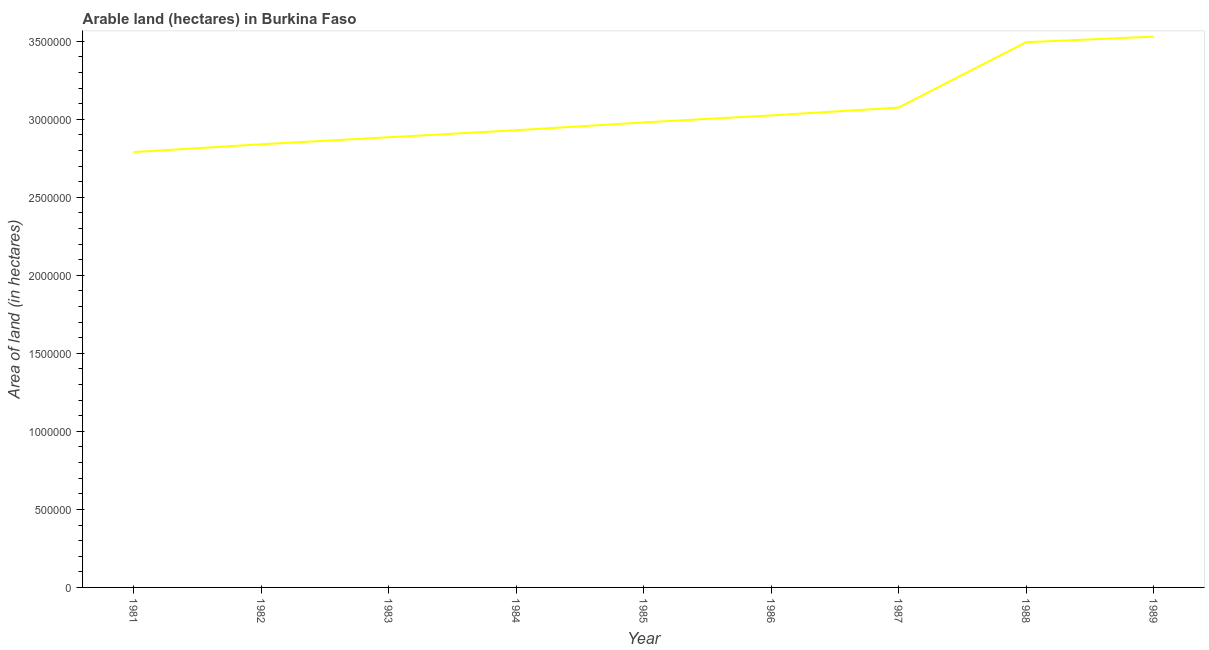What is the area of land in 1986?
Your response must be concise. 3.02e+06. Across all years, what is the maximum area of land?
Offer a very short reply. 3.53e+06. Across all years, what is the minimum area of land?
Your response must be concise. 2.79e+06. What is the sum of the area of land?
Ensure brevity in your answer.  2.75e+07. What is the difference between the area of land in 1981 and 1987?
Provide a short and direct response. -2.85e+05. What is the average area of land per year?
Keep it short and to the point. 3.06e+06. What is the median area of land?
Provide a succinct answer. 2.98e+06. In how many years, is the area of land greater than 2200000 hectares?
Offer a very short reply. 9. What is the ratio of the area of land in 1984 to that in 1987?
Offer a very short reply. 0.95. Is the area of land in 1986 less than that in 1989?
Provide a succinct answer. Yes. What is the difference between the highest and the second highest area of land?
Give a very brief answer. 3.60e+04. Is the sum of the area of land in 1984 and 1985 greater than the maximum area of land across all years?
Provide a succinct answer. Yes. What is the difference between the highest and the lowest area of land?
Your answer should be very brief. 7.40e+05. In how many years, is the area of land greater than the average area of land taken over all years?
Make the answer very short. 3. Does the area of land monotonically increase over the years?
Give a very brief answer. Yes. How many years are there in the graph?
Offer a terse response. 9. What is the difference between two consecutive major ticks on the Y-axis?
Keep it short and to the point. 5.00e+05. Does the graph contain grids?
Offer a very short reply. No. What is the title of the graph?
Provide a short and direct response. Arable land (hectares) in Burkina Faso. What is the label or title of the Y-axis?
Your answer should be compact. Area of land (in hectares). What is the Area of land (in hectares) in 1981?
Make the answer very short. 2.79e+06. What is the Area of land (in hectares) of 1982?
Your response must be concise. 2.84e+06. What is the Area of land (in hectares) in 1983?
Your answer should be compact. 2.88e+06. What is the Area of land (in hectares) of 1984?
Make the answer very short. 2.93e+06. What is the Area of land (in hectares) in 1985?
Keep it short and to the point. 2.98e+06. What is the Area of land (in hectares) of 1986?
Provide a succinct answer. 3.02e+06. What is the Area of land (in hectares) of 1987?
Your answer should be compact. 3.08e+06. What is the Area of land (in hectares) in 1988?
Your answer should be very brief. 3.49e+06. What is the Area of land (in hectares) of 1989?
Give a very brief answer. 3.53e+06. What is the difference between the Area of land (in hectares) in 1981 and 1983?
Your response must be concise. -9.50e+04. What is the difference between the Area of land (in hectares) in 1981 and 1986?
Keep it short and to the point. -2.35e+05. What is the difference between the Area of land (in hectares) in 1981 and 1987?
Ensure brevity in your answer.  -2.85e+05. What is the difference between the Area of land (in hectares) in 1981 and 1988?
Provide a succinct answer. -7.04e+05. What is the difference between the Area of land (in hectares) in 1981 and 1989?
Ensure brevity in your answer.  -7.40e+05. What is the difference between the Area of land (in hectares) in 1982 and 1983?
Provide a succinct answer. -4.50e+04. What is the difference between the Area of land (in hectares) in 1982 and 1986?
Offer a terse response. -1.85e+05. What is the difference between the Area of land (in hectares) in 1982 and 1987?
Offer a very short reply. -2.35e+05. What is the difference between the Area of land (in hectares) in 1982 and 1988?
Make the answer very short. -6.54e+05. What is the difference between the Area of land (in hectares) in 1982 and 1989?
Keep it short and to the point. -6.90e+05. What is the difference between the Area of land (in hectares) in 1983 and 1984?
Provide a short and direct response. -4.50e+04. What is the difference between the Area of land (in hectares) in 1983 and 1985?
Make the answer very short. -9.50e+04. What is the difference between the Area of land (in hectares) in 1983 and 1987?
Ensure brevity in your answer.  -1.90e+05. What is the difference between the Area of land (in hectares) in 1983 and 1988?
Your answer should be very brief. -6.09e+05. What is the difference between the Area of land (in hectares) in 1983 and 1989?
Ensure brevity in your answer.  -6.45e+05. What is the difference between the Area of land (in hectares) in 1984 and 1986?
Ensure brevity in your answer.  -9.50e+04. What is the difference between the Area of land (in hectares) in 1984 and 1987?
Keep it short and to the point. -1.45e+05. What is the difference between the Area of land (in hectares) in 1984 and 1988?
Offer a terse response. -5.64e+05. What is the difference between the Area of land (in hectares) in 1984 and 1989?
Ensure brevity in your answer.  -6.00e+05. What is the difference between the Area of land (in hectares) in 1985 and 1986?
Provide a short and direct response. -4.50e+04. What is the difference between the Area of land (in hectares) in 1985 and 1987?
Your answer should be compact. -9.50e+04. What is the difference between the Area of land (in hectares) in 1985 and 1988?
Make the answer very short. -5.14e+05. What is the difference between the Area of land (in hectares) in 1985 and 1989?
Provide a short and direct response. -5.50e+05. What is the difference between the Area of land (in hectares) in 1986 and 1987?
Your answer should be very brief. -5.00e+04. What is the difference between the Area of land (in hectares) in 1986 and 1988?
Keep it short and to the point. -4.69e+05. What is the difference between the Area of land (in hectares) in 1986 and 1989?
Offer a terse response. -5.05e+05. What is the difference between the Area of land (in hectares) in 1987 and 1988?
Give a very brief answer. -4.19e+05. What is the difference between the Area of land (in hectares) in 1987 and 1989?
Keep it short and to the point. -4.55e+05. What is the difference between the Area of land (in hectares) in 1988 and 1989?
Give a very brief answer. -3.60e+04. What is the ratio of the Area of land (in hectares) in 1981 to that in 1982?
Keep it short and to the point. 0.98. What is the ratio of the Area of land (in hectares) in 1981 to that in 1985?
Make the answer very short. 0.94. What is the ratio of the Area of land (in hectares) in 1981 to that in 1986?
Offer a terse response. 0.92. What is the ratio of the Area of land (in hectares) in 1981 to that in 1987?
Make the answer very short. 0.91. What is the ratio of the Area of land (in hectares) in 1981 to that in 1988?
Ensure brevity in your answer.  0.8. What is the ratio of the Area of land (in hectares) in 1981 to that in 1989?
Make the answer very short. 0.79. What is the ratio of the Area of land (in hectares) in 1982 to that in 1983?
Make the answer very short. 0.98. What is the ratio of the Area of land (in hectares) in 1982 to that in 1985?
Your answer should be compact. 0.95. What is the ratio of the Area of land (in hectares) in 1982 to that in 1986?
Your answer should be compact. 0.94. What is the ratio of the Area of land (in hectares) in 1982 to that in 1987?
Ensure brevity in your answer.  0.92. What is the ratio of the Area of land (in hectares) in 1982 to that in 1988?
Provide a succinct answer. 0.81. What is the ratio of the Area of land (in hectares) in 1982 to that in 1989?
Provide a succinct answer. 0.81. What is the ratio of the Area of land (in hectares) in 1983 to that in 1984?
Make the answer very short. 0.98. What is the ratio of the Area of land (in hectares) in 1983 to that in 1986?
Offer a terse response. 0.95. What is the ratio of the Area of land (in hectares) in 1983 to that in 1987?
Provide a succinct answer. 0.94. What is the ratio of the Area of land (in hectares) in 1983 to that in 1988?
Offer a terse response. 0.83. What is the ratio of the Area of land (in hectares) in 1983 to that in 1989?
Your answer should be very brief. 0.82. What is the ratio of the Area of land (in hectares) in 1984 to that in 1985?
Make the answer very short. 0.98. What is the ratio of the Area of land (in hectares) in 1984 to that in 1987?
Your answer should be very brief. 0.95. What is the ratio of the Area of land (in hectares) in 1984 to that in 1988?
Offer a very short reply. 0.84. What is the ratio of the Area of land (in hectares) in 1984 to that in 1989?
Ensure brevity in your answer.  0.83. What is the ratio of the Area of land (in hectares) in 1985 to that in 1987?
Provide a short and direct response. 0.97. What is the ratio of the Area of land (in hectares) in 1985 to that in 1988?
Your response must be concise. 0.85. What is the ratio of the Area of land (in hectares) in 1985 to that in 1989?
Your answer should be compact. 0.84. What is the ratio of the Area of land (in hectares) in 1986 to that in 1987?
Keep it short and to the point. 0.98. What is the ratio of the Area of land (in hectares) in 1986 to that in 1988?
Offer a very short reply. 0.87. What is the ratio of the Area of land (in hectares) in 1986 to that in 1989?
Make the answer very short. 0.86. What is the ratio of the Area of land (in hectares) in 1987 to that in 1989?
Give a very brief answer. 0.87. What is the ratio of the Area of land (in hectares) in 1988 to that in 1989?
Your answer should be compact. 0.99. 